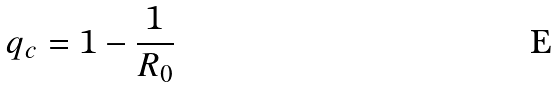Convert formula to latex. <formula><loc_0><loc_0><loc_500><loc_500>q _ { c } = 1 - \frac { 1 } { R _ { 0 } }</formula> 